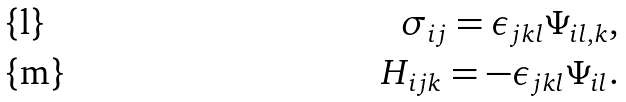<formula> <loc_0><loc_0><loc_500><loc_500>\sigma _ { i j } = \epsilon _ { j k l } \Psi _ { i l , k } , \\ H _ { i j k } = - \epsilon _ { j k l } \Psi _ { i l } .</formula> 